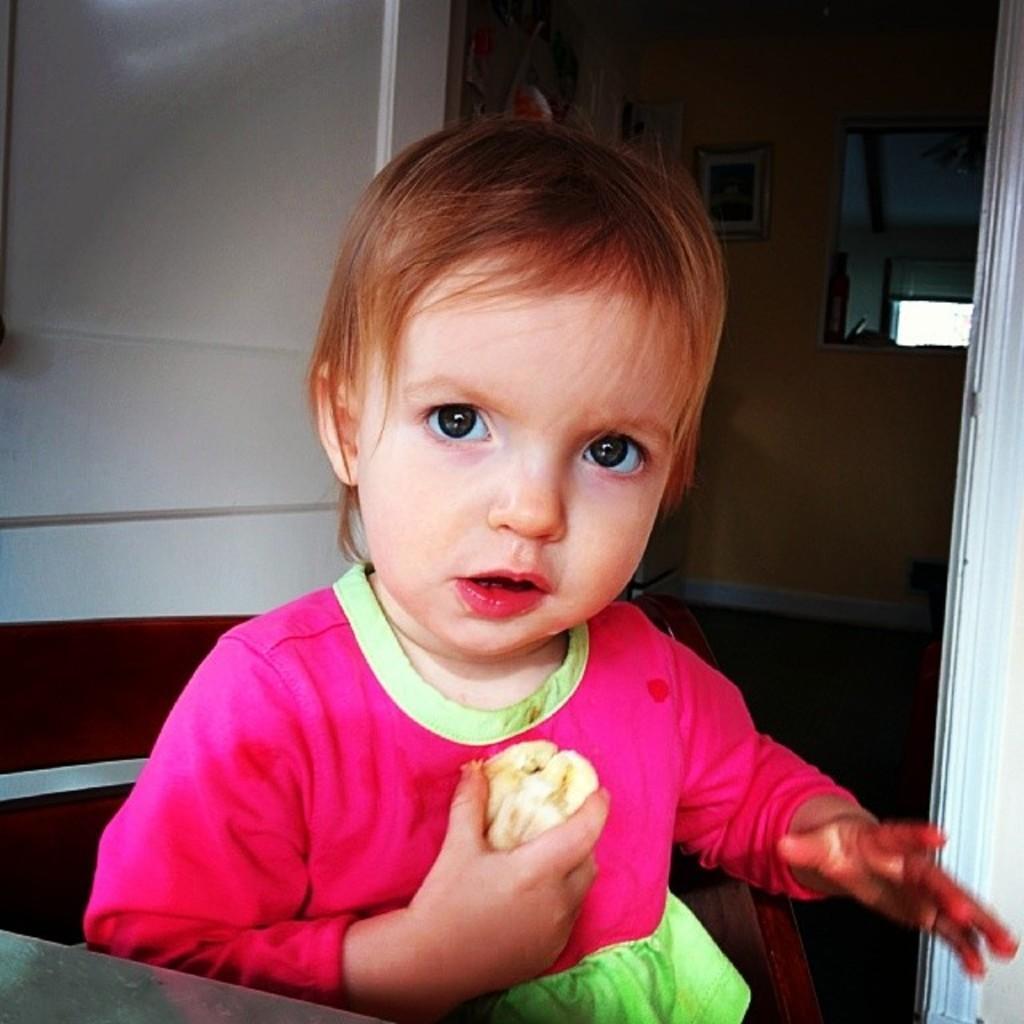Can you describe this image briefly? In this image I can see a kid. In the background, I can see the wall. 